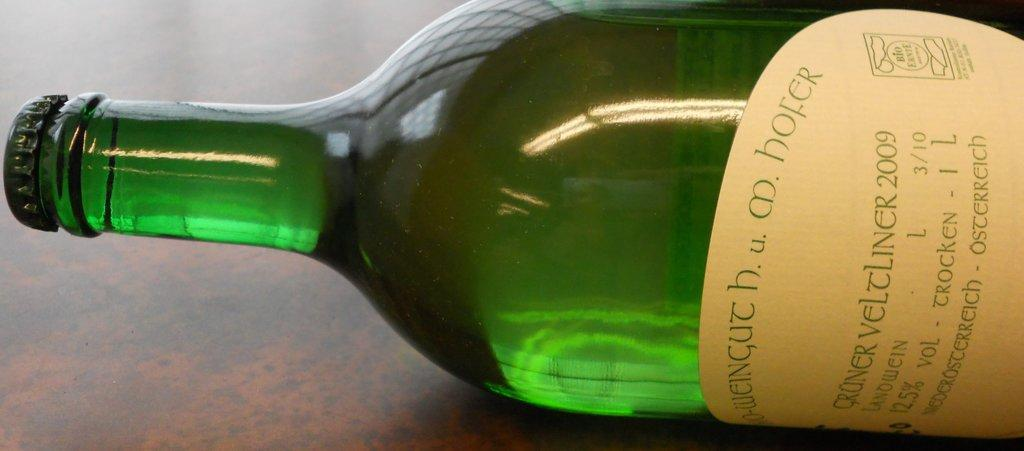<image>
Describe the image concisely. A bottle of Cruner Veltliner 2009 lying sideways on a table. 